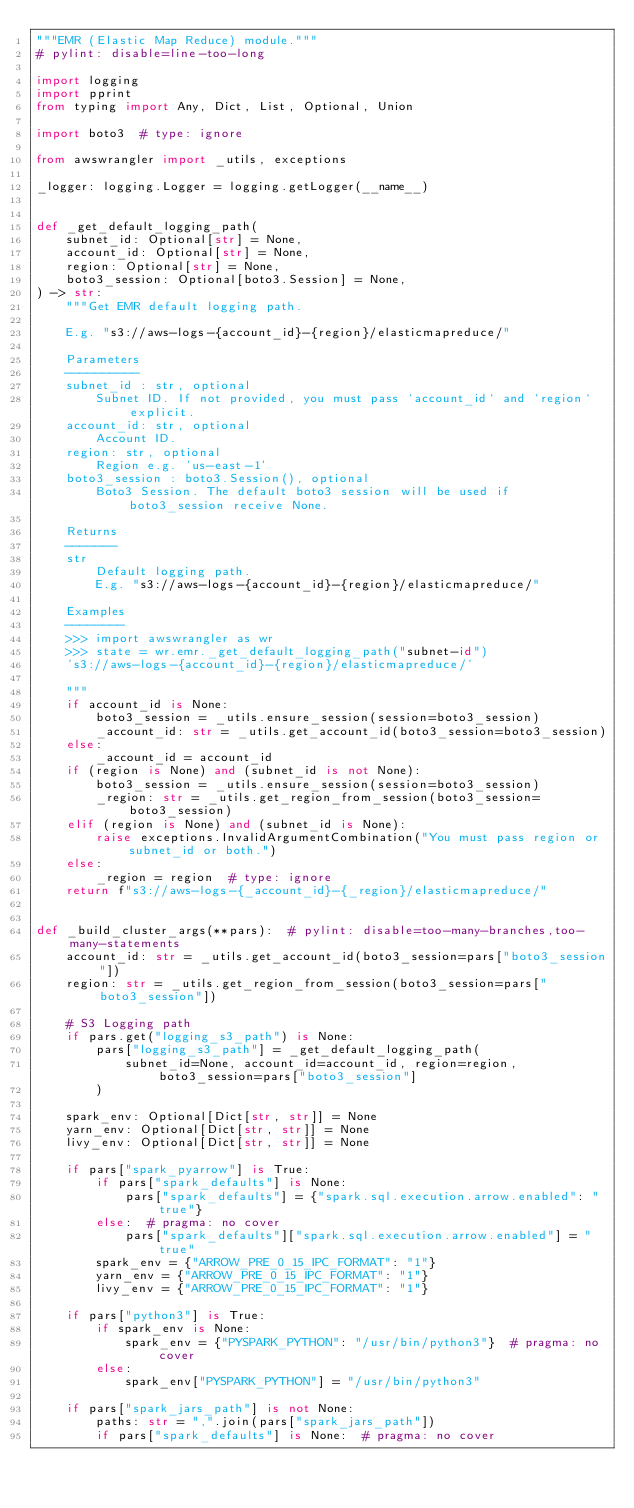Convert code to text. <code><loc_0><loc_0><loc_500><loc_500><_Python_>"""EMR (Elastic Map Reduce) module."""
# pylint: disable=line-too-long

import logging
import pprint
from typing import Any, Dict, List, Optional, Union

import boto3  # type: ignore

from awswrangler import _utils, exceptions

_logger: logging.Logger = logging.getLogger(__name__)


def _get_default_logging_path(
    subnet_id: Optional[str] = None,
    account_id: Optional[str] = None,
    region: Optional[str] = None,
    boto3_session: Optional[boto3.Session] = None,
) -> str:
    """Get EMR default logging path.

    E.g. "s3://aws-logs-{account_id}-{region}/elasticmapreduce/"

    Parameters
    ----------
    subnet_id : str, optional
        Subnet ID. If not provided, you must pass `account_id` and `region` explicit.
    account_id: str, optional
        Account ID.
    region: str, optional
        Region e.g. 'us-east-1'
    boto3_session : boto3.Session(), optional
        Boto3 Session. The default boto3 session will be used if boto3_session receive None.

    Returns
    -------
    str
        Default logging path.
        E.g. "s3://aws-logs-{account_id}-{region}/elasticmapreduce/"

    Examples
    --------
    >>> import awswrangler as wr
    >>> state = wr.emr._get_default_logging_path("subnet-id")
    's3://aws-logs-{account_id}-{region}/elasticmapreduce/'

    """
    if account_id is None:
        boto3_session = _utils.ensure_session(session=boto3_session)
        _account_id: str = _utils.get_account_id(boto3_session=boto3_session)
    else:
        _account_id = account_id
    if (region is None) and (subnet_id is not None):
        boto3_session = _utils.ensure_session(session=boto3_session)
        _region: str = _utils.get_region_from_session(boto3_session=boto3_session)
    elif (region is None) and (subnet_id is None):
        raise exceptions.InvalidArgumentCombination("You must pass region or subnet_id or both.")
    else:
        _region = region  # type: ignore
    return f"s3://aws-logs-{_account_id}-{_region}/elasticmapreduce/"


def _build_cluster_args(**pars):  # pylint: disable=too-many-branches,too-many-statements
    account_id: str = _utils.get_account_id(boto3_session=pars["boto3_session"])
    region: str = _utils.get_region_from_session(boto3_session=pars["boto3_session"])

    # S3 Logging path
    if pars.get("logging_s3_path") is None:
        pars["logging_s3_path"] = _get_default_logging_path(
            subnet_id=None, account_id=account_id, region=region, boto3_session=pars["boto3_session"]
        )

    spark_env: Optional[Dict[str, str]] = None
    yarn_env: Optional[Dict[str, str]] = None
    livy_env: Optional[Dict[str, str]] = None

    if pars["spark_pyarrow"] is True:
        if pars["spark_defaults"] is None:
            pars["spark_defaults"] = {"spark.sql.execution.arrow.enabled": "true"}
        else:  # pragma: no cover
            pars["spark_defaults"]["spark.sql.execution.arrow.enabled"] = "true"
        spark_env = {"ARROW_PRE_0_15_IPC_FORMAT": "1"}
        yarn_env = {"ARROW_PRE_0_15_IPC_FORMAT": "1"}
        livy_env = {"ARROW_PRE_0_15_IPC_FORMAT": "1"}

    if pars["python3"] is True:
        if spark_env is None:
            spark_env = {"PYSPARK_PYTHON": "/usr/bin/python3"}  # pragma: no cover
        else:
            spark_env["PYSPARK_PYTHON"] = "/usr/bin/python3"

    if pars["spark_jars_path"] is not None:
        paths: str = ",".join(pars["spark_jars_path"])
        if pars["spark_defaults"] is None:  # pragma: no cover</code> 